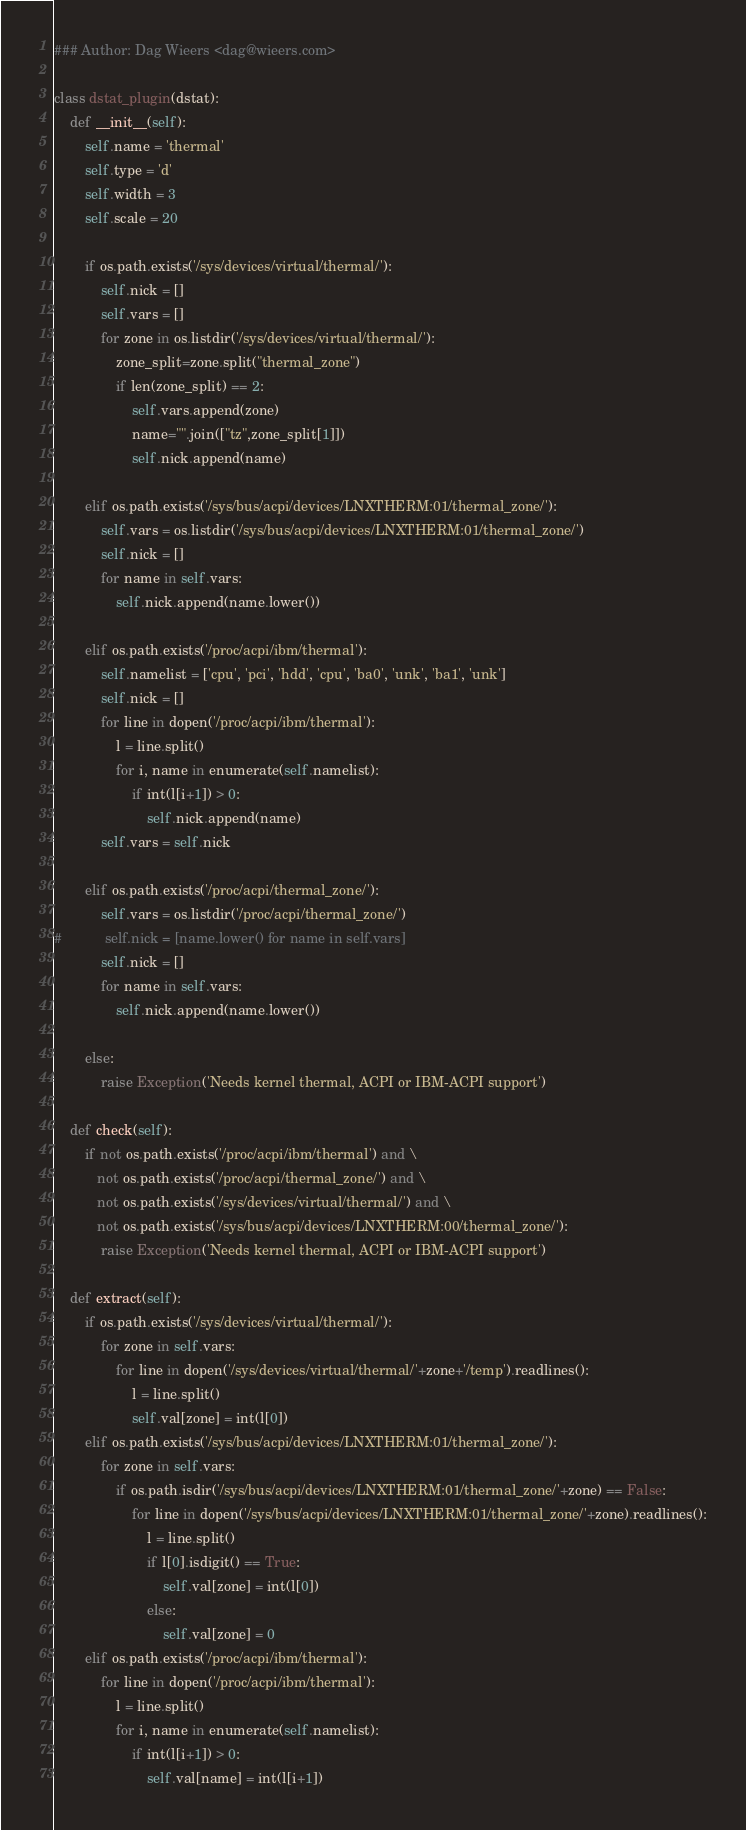<code> <loc_0><loc_0><loc_500><loc_500><_Python_>### Author: Dag Wieers <dag@wieers.com>

class dstat_plugin(dstat):
    def __init__(self):
        self.name = 'thermal'
        self.type = 'd'
        self.width = 3
        self.scale = 20

        if os.path.exists('/sys/devices/virtual/thermal/'):
            self.nick = []
            self.vars = []
            for zone in os.listdir('/sys/devices/virtual/thermal/'):
                zone_split=zone.split("thermal_zone")
                if len(zone_split) == 2:
                    self.vars.append(zone)
                    name="".join(["tz",zone_split[1]])
                    self.nick.append(name)

        elif os.path.exists('/sys/bus/acpi/devices/LNXTHERM:01/thermal_zone/'):
            self.vars = os.listdir('/sys/bus/acpi/devices/LNXTHERM:01/thermal_zone/')
            self.nick = []
            for name in self.vars:
                self.nick.append(name.lower())

        elif os.path.exists('/proc/acpi/ibm/thermal'):
            self.namelist = ['cpu', 'pci', 'hdd', 'cpu', 'ba0', 'unk', 'ba1', 'unk']
            self.nick = []
            for line in dopen('/proc/acpi/ibm/thermal'):
                l = line.split()
                for i, name in enumerate(self.namelist):
                    if int(l[i+1]) > 0:
                        self.nick.append(name)
            self.vars = self.nick

        elif os.path.exists('/proc/acpi/thermal_zone/'):
            self.vars = os.listdir('/proc/acpi/thermal_zone/')
#           self.nick = [name.lower() for name in self.vars]
            self.nick = []
            for name in self.vars:
                self.nick.append(name.lower())

        else:
            raise Exception('Needs kernel thermal, ACPI or IBM-ACPI support')

    def check(self):
        if not os.path.exists('/proc/acpi/ibm/thermal') and \
           not os.path.exists('/proc/acpi/thermal_zone/') and \
           not os.path.exists('/sys/devices/virtual/thermal/') and \
           not os.path.exists('/sys/bus/acpi/devices/LNXTHERM:00/thermal_zone/'):
            raise Exception('Needs kernel thermal, ACPI or IBM-ACPI support')

    def extract(self):
        if os.path.exists('/sys/devices/virtual/thermal/'):
            for zone in self.vars:
                for line in dopen('/sys/devices/virtual/thermal/'+zone+'/temp').readlines():
                    l = line.split()
                    self.val[zone] = int(l[0])
        elif os.path.exists('/sys/bus/acpi/devices/LNXTHERM:01/thermal_zone/'):
            for zone in self.vars:
                if os.path.isdir('/sys/bus/acpi/devices/LNXTHERM:01/thermal_zone/'+zone) == False:
                    for line in dopen('/sys/bus/acpi/devices/LNXTHERM:01/thermal_zone/'+zone).readlines():
                        l = line.split()
                        if l[0].isdigit() == True:
                            self.val[zone] = int(l[0])
                        else:
                            self.val[zone] = 0
        elif os.path.exists('/proc/acpi/ibm/thermal'):
            for line in dopen('/proc/acpi/ibm/thermal'):
                l = line.split()
                for i, name in enumerate(self.namelist):
                    if int(l[i+1]) > 0:
                        self.val[name] = int(l[i+1])</code> 